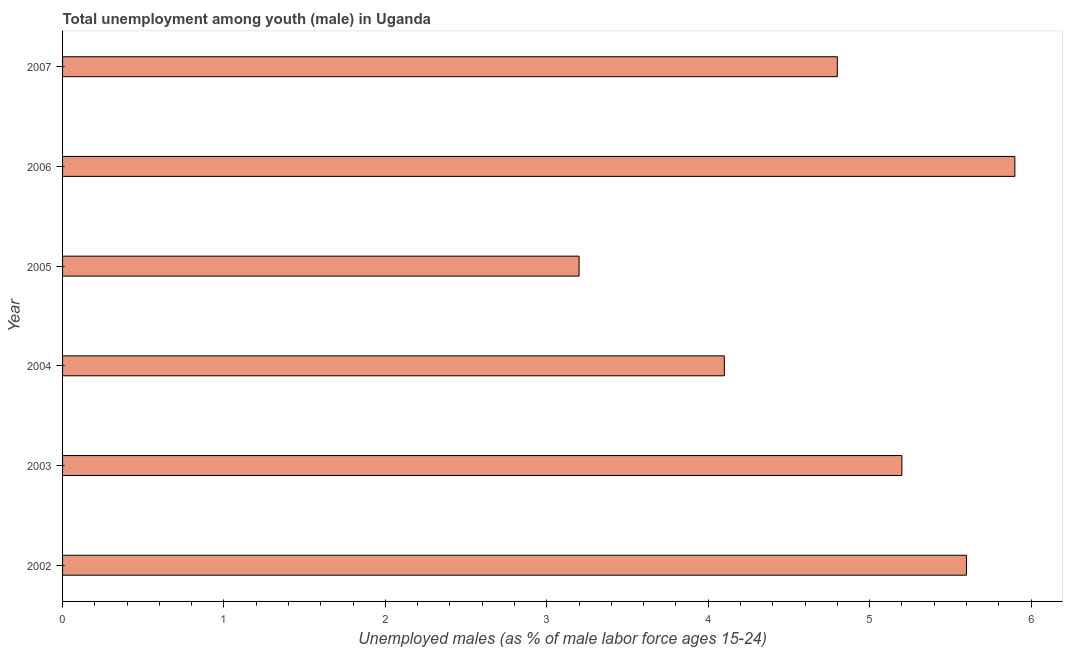Does the graph contain grids?
Offer a terse response. No. What is the title of the graph?
Make the answer very short. Total unemployment among youth (male) in Uganda. What is the label or title of the X-axis?
Make the answer very short. Unemployed males (as % of male labor force ages 15-24). What is the label or title of the Y-axis?
Provide a succinct answer. Year. What is the unemployed male youth population in 2007?
Make the answer very short. 4.8. Across all years, what is the maximum unemployed male youth population?
Give a very brief answer. 5.9. Across all years, what is the minimum unemployed male youth population?
Your response must be concise. 3.2. What is the sum of the unemployed male youth population?
Provide a succinct answer. 28.8. What is the difference between the unemployed male youth population in 2006 and 2007?
Provide a short and direct response. 1.1. What is the average unemployed male youth population per year?
Your answer should be very brief. 4.8. What is the median unemployed male youth population?
Your answer should be very brief. 5. Do a majority of the years between 2007 and 2004 (inclusive) have unemployed male youth population greater than 1.8 %?
Provide a succinct answer. Yes. What is the ratio of the unemployed male youth population in 2005 to that in 2007?
Make the answer very short. 0.67. What is the difference between the highest and the second highest unemployed male youth population?
Offer a very short reply. 0.3. What is the difference between the highest and the lowest unemployed male youth population?
Give a very brief answer. 2.7. Are the values on the major ticks of X-axis written in scientific E-notation?
Give a very brief answer. No. What is the Unemployed males (as % of male labor force ages 15-24) in 2002?
Ensure brevity in your answer.  5.6. What is the Unemployed males (as % of male labor force ages 15-24) in 2003?
Provide a short and direct response. 5.2. What is the Unemployed males (as % of male labor force ages 15-24) in 2004?
Offer a terse response. 4.1. What is the Unemployed males (as % of male labor force ages 15-24) in 2005?
Offer a terse response. 3.2. What is the Unemployed males (as % of male labor force ages 15-24) in 2006?
Offer a very short reply. 5.9. What is the Unemployed males (as % of male labor force ages 15-24) of 2007?
Keep it short and to the point. 4.8. What is the difference between the Unemployed males (as % of male labor force ages 15-24) in 2002 and 2003?
Your response must be concise. 0.4. What is the difference between the Unemployed males (as % of male labor force ages 15-24) in 2002 and 2005?
Offer a very short reply. 2.4. What is the difference between the Unemployed males (as % of male labor force ages 15-24) in 2002 and 2006?
Provide a succinct answer. -0.3. What is the difference between the Unemployed males (as % of male labor force ages 15-24) in 2002 and 2007?
Provide a short and direct response. 0.8. What is the difference between the Unemployed males (as % of male labor force ages 15-24) in 2003 and 2004?
Provide a short and direct response. 1.1. What is the difference between the Unemployed males (as % of male labor force ages 15-24) in 2003 and 2007?
Offer a very short reply. 0.4. What is the difference between the Unemployed males (as % of male labor force ages 15-24) in 2004 and 2005?
Provide a short and direct response. 0.9. What is the difference between the Unemployed males (as % of male labor force ages 15-24) in 2004 and 2006?
Make the answer very short. -1.8. What is the difference between the Unemployed males (as % of male labor force ages 15-24) in 2005 and 2006?
Provide a short and direct response. -2.7. What is the difference between the Unemployed males (as % of male labor force ages 15-24) in 2005 and 2007?
Ensure brevity in your answer.  -1.6. What is the ratio of the Unemployed males (as % of male labor force ages 15-24) in 2002 to that in 2003?
Your response must be concise. 1.08. What is the ratio of the Unemployed males (as % of male labor force ages 15-24) in 2002 to that in 2004?
Keep it short and to the point. 1.37. What is the ratio of the Unemployed males (as % of male labor force ages 15-24) in 2002 to that in 2006?
Offer a terse response. 0.95. What is the ratio of the Unemployed males (as % of male labor force ages 15-24) in 2002 to that in 2007?
Give a very brief answer. 1.17. What is the ratio of the Unemployed males (as % of male labor force ages 15-24) in 2003 to that in 2004?
Your answer should be compact. 1.27. What is the ratio of the Unemployed males (as % of male labor force ages 15-24) in 2003 to that in 2005?
Provide a short and direct response. 1.62. What is the ratio of the Unemployed males (as % of male labor force ages 15-24) in 2003 to that in 2006?
Ensure brevity in your answer.  0.88. What is the ratio of the Unemployed males (as % of male labor force ages 15-24) in 2003 to that in 2007?
Your answer should be very brief. 1.08. What is the ratio of the Unemployed males (as % of male labor force ages 15-24) in 2004 to that in 2005?
Your answer should be very brief. 1.28. What is the ratio of the Unemployed males (as % of male labor force ages 15-24) in 2004 to that in 2006?
Your response must be concise. 0.69. What is the ratio of the Unemployed males (as % of male labor force ages 15-24) in 2004 to that in 2007?
Give a very brief answer. 0.85. What is the ratio of the Unemployed males (as % of male labor force ages 15-24) in 2005 to that in 2006?
Your answer should be very brief. 0.54. What is the ratio of the Unemployed males (as % of male labor force ages 15-24) in 2005 to that in 2007?
Offer a very short reply. 0.67. What is the ratio of the Unemployed males (as % of male labor force ages 15-24) in 2006 to that in 2007?
Your response must be concise. 1.23. 